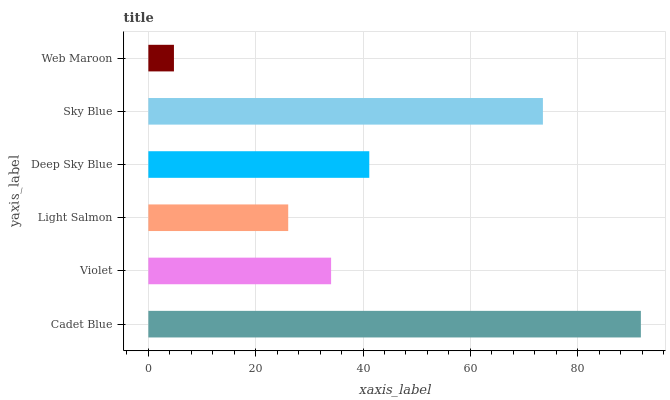Is Web Maroon the minimum?
Answer yes or no. Yes. Is Cadet Blue the maximum?
Answer yes or no. Yes. Is Violet the minimum?
Answer yes or no. No. Is Violet the maximum?
Answer yes or no. No. Is Cadet Blue greater than Violet?
Answer yes or no. Yes. Is Violet less than Cadet Blue?
Answer yes or no. Yes. Is Violet greater than Cadet Blue?
Answer yes or no. No. Is Cadet Blue less than Violet?
Answer yes or no. No. Is Deep Sky Blue the high median?
Answer yes or no. Yes. Is Violet the low median?
Answer yes or no. Yes. Is Sky Blue the high median?
Answer yes or no. No. Is Light Salmon the low median?
Answer yes or no. No. 